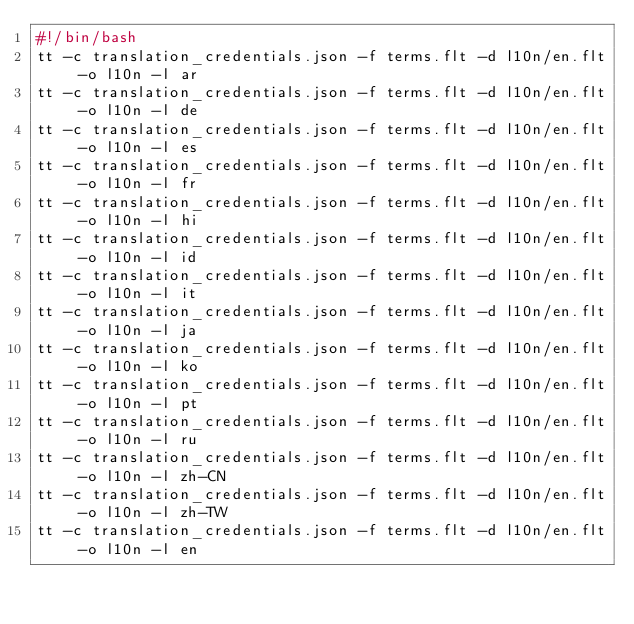<code> <loc_0><loc_0><loc_500><loc_500><_Bash_>#!/bin/bash
tt -c translation_credentials.json -f terms.flt -d l10n/en.flt -o l10n -l ar
tt -c translation_credentials.json -f terms.flt -d l10n/en.flt -o l10n -l de
tt -c translation_credentials.json -f terms.flt -d l10n/en.flt -o l10n -l es
tt -c translation_credentials.json -f terms.flt -d l10n/en.flt -o l10n -l fr
tt -c translation_credentials.json -f terms.flt -d l10n/en.flt -o l10n -l hi
tt -c translation_credentials.json -f terms.flt -d l10n/en.flt -o l10n -l id
tt -c translation_credentials.json -f terms.flt -d l10n/en.flt -o l10n -l it
tt -c translation_credentials.json -f terms.flt -d l10n/en.flt -o l10n -l ja
tt -c translation_credentials.json -f terms.flt -d l10n/en.flt -o l10n -l ko
tt -c translation_credentials.json -f terms.flt -d l10n/en.flt -o l10n -l pt
tt -c translation_credentials.json -f terms.flt -d l10n/en.flt -o l10n -l ru
tt -c translation_credentials.json -f terms.flt -d l10n/en.flt -o l10n -l zh-CN
tt -c translation_credentials.json -f terms.flt -d l10n/en.flt -o l10n -l zh-TW
tt -c translation_credentials.json -f terms.flt -d l10n/en.flt -o l10n -l en</code> 